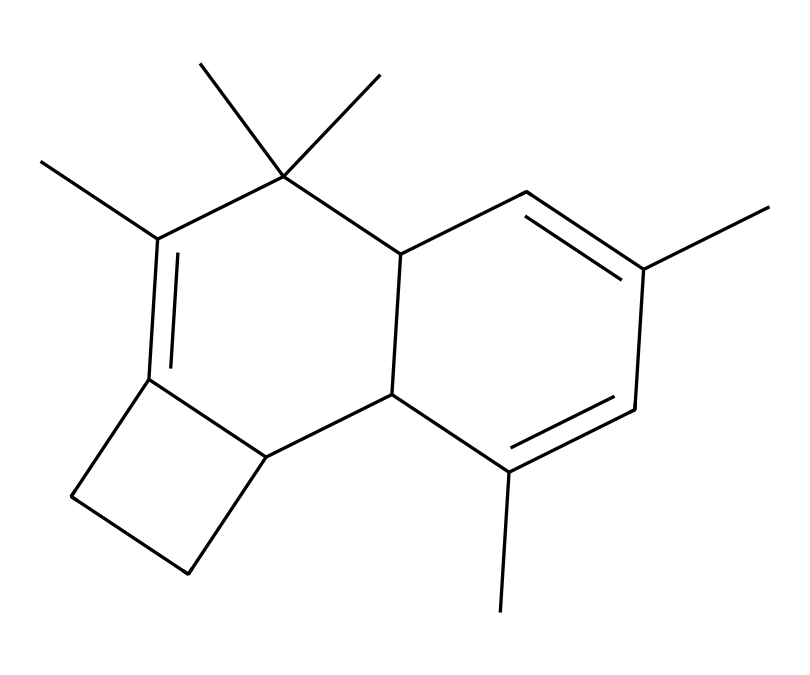What is the primary functional group in myrrh? The structure shows a cyclic compound with multiple carbon rings, which typically indicates that it may contain aromatic characteristics. In many aromatic compounds, including those similar to myrrh, the presence of alcohol groups can indicate its properties, but here, alcohols are not explicitly shown. Overall, the primary functional group visible in the structure would be aromatic hydrocarbons.
Answer: aromatic hydrocarbons How many rings are present in the structure of myrrh? By analyzing the SMILES representation, I can identify several rings. Counting the interconnected segments in the structure indicates there are three distinct cyclic structures present.
Answer: three What aspect of myrrh contributes to its aromatic scent? The presence of multiple double bonds within the cyclic structure allows for resonance and contributes significantly to the aromatic properties of compounds like myrrh. This resonance stabilizes the structure, enhancing its volatility and fragrance.
Answer: double bonds What is the total number of carbon atoms in the structure? By closely examining the SMILES representation, I can individually count the number of carbon atoms represented. Each "C" signifies a carbon atom, and I find there are 15 carbon atoms total in the chemical structure of myrrh.
Answer: 15 Which type of bonding is primarily indicated by the multiple double bonds in myrrh? The presence of double bonds (indicated by "=" in the SMILES) suggests that there are areas of the molecule where carbon atoms are double-bonded to one another. This type of bonding contributes to the chemical’s planar structure, significantly affecting its aromatic qualities.
Answer: covalent bonding 